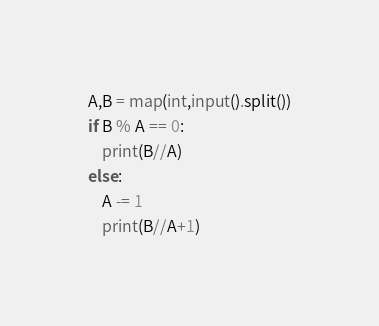<code> <loc_0><loc_0><loc_500><loc_500><_Python_>A,B = map(int,input().split())
if B % A == 0:
    print(B//A)
else:
    A -= 1
    print(B//A+1)</code> 